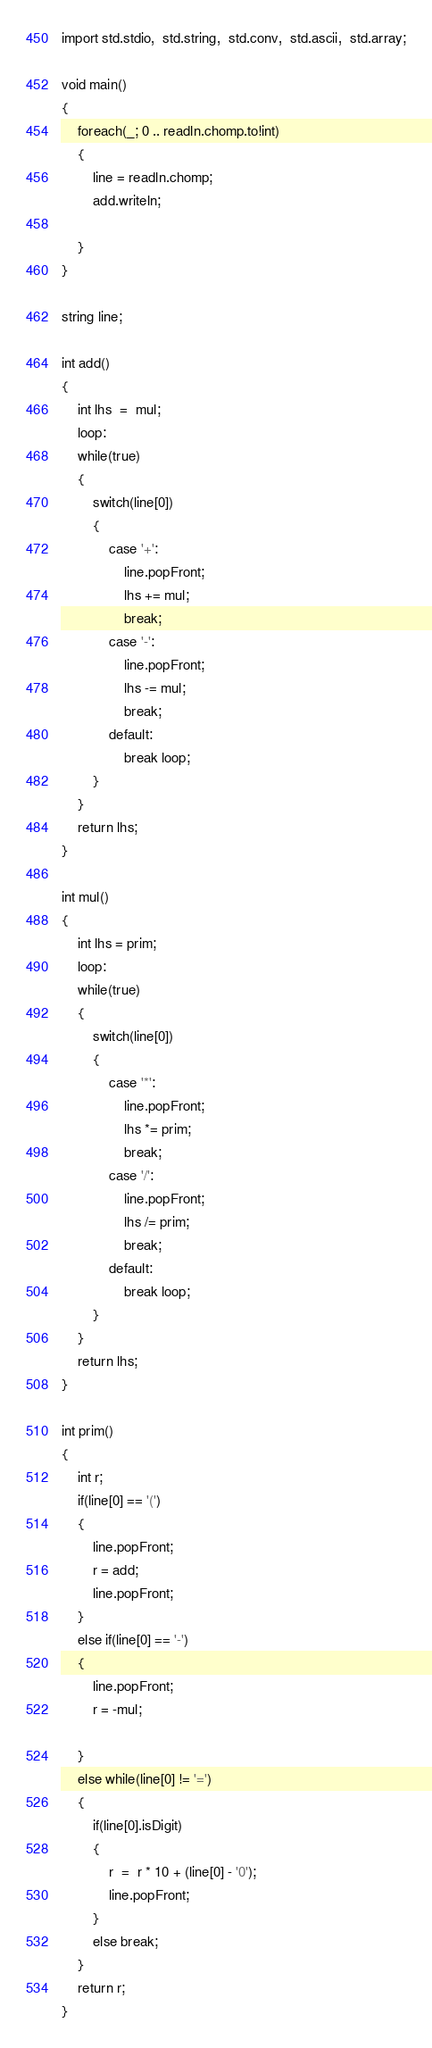<code> <loc_0><loc_0><loc_500><loc_500><_D_>import std.stdio,  std.string,  std.conv,  std.ascii,  std.array;

void main()
{
    foreach(_; 0 .. readln.chomp.to!int)
    {
        line = readln.chomp;
        add.writeln;

    }
}

string line;

int add()
{
    int lhs  =  mul;
    loop:
    while(true)
    {
        switch(line[0])
        {
            case '+':
                line.popFront;
                lhs += mul;
                break;
            case '-':
                line.popFront;
                lhs -= mul;
                break;
            default:
                break loop;
        }
    }
    return lhs;
}

int mul()
{
    int lhs = prim;
    loop:
    while(true)
    {
        switch(line[0])
        {
            case '*':
                line.popFront;
                lhs *= prim;
                break;
            case '/':
                line.popFront;
                lhs /= prim;
                break;
            default:
                break loop;
        }
    }
    return lhs;
}

int prim()
{
    int r;
    if(line[0] == '(')
    {
        line.popFront;
        r = add;
        line.popFront;
    }
    else if(line[0] == '-')
    {
        line.popFront;
        r = -mul;

    }
    else while(line[0] != '=')
    {
        if(line[0].isDigit)
        {
            r  =  r * 10 + (line[0] - '0');
            line.popFront;
        } 
        else break;
    }
    return r;
}</code> 